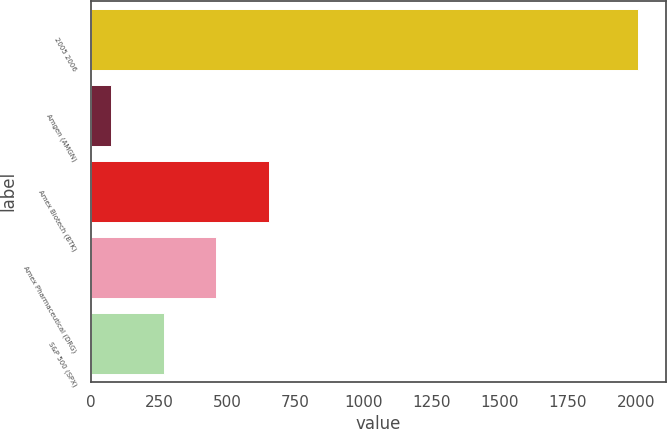Convert chart. <chart><loc_0><loc_0><loc_500><loc_500><bar_chart><fcel>2005 2006<fcel>Amgen (AMGN)<fcel>Amex Biotech (BTK)<fcel>Amex Pharmaceutical (DRG)<fcel>S&P 500 (SPX)<nl><fcel>2009<fcel>73.23<fcel>653.97<fcel>460.39<fcel>266.81<nl></chart> 